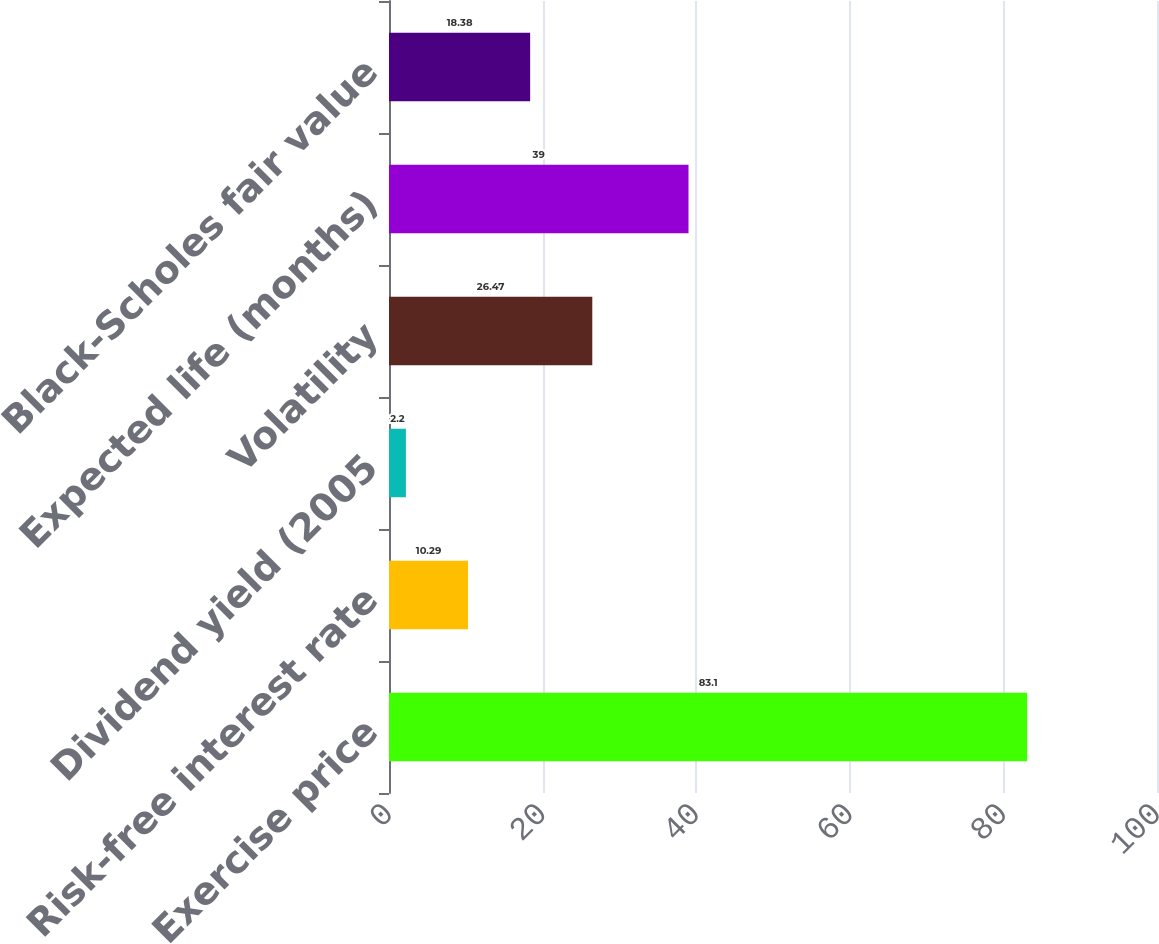<chart> <loc_0><loc_0><loc_500><loc_500><bar_chart><fcel>Exercise price<fcel>Risk-free interest rate<fcel>Dividend yield (2005<fcel>Volatility<fcel>Expected life (months)<fcel>Black-Scholes fair value<nl><fcel>83.1<fcel>10.29<fcel>2.2<fcel>26.47<fcel>39<fcel>18.38<nl></chart> 